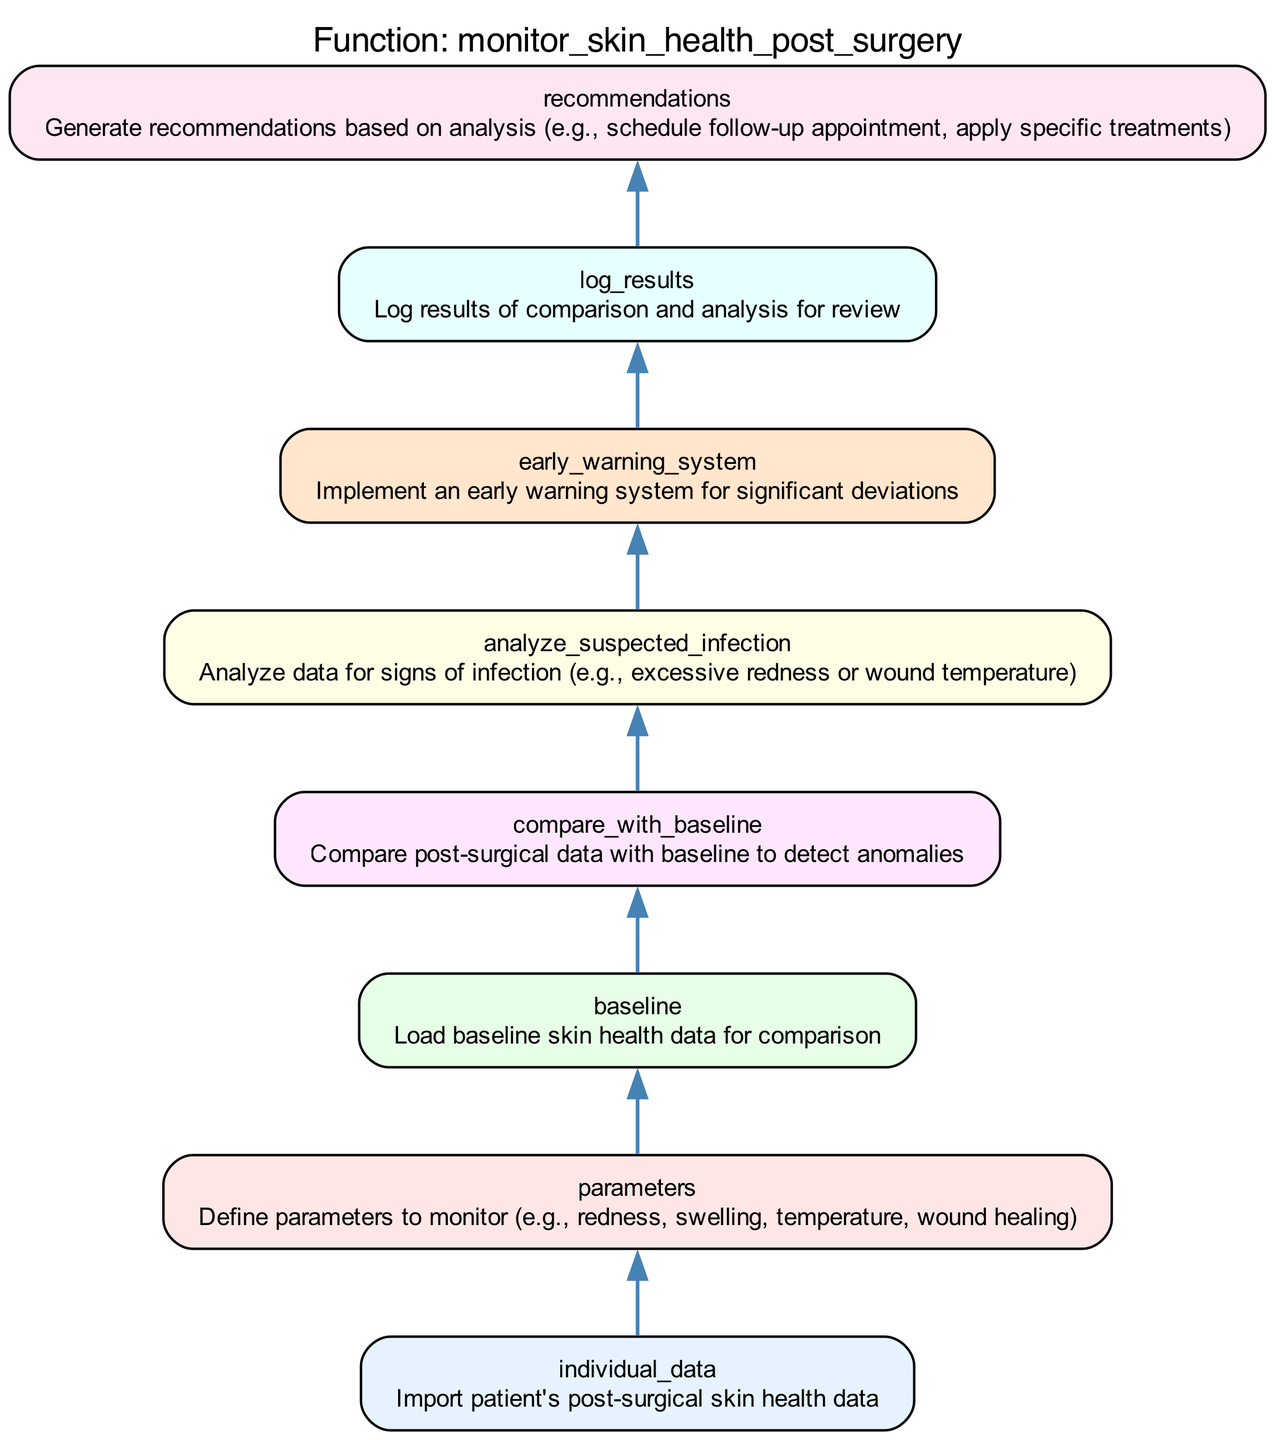What is the first step in the function? The first step, labeled "individual_data", indicates that the function starts by importing the patient's post-surgical skin health data, which is the initial action taken before any processing.
Answer: Import patient's post-surgical skin health data How many nodes are there in total? By counting all the distinct elements in the flowchart, we find that there are a total of eight nodes representing different stages in the monitoring process.
Answer: Eight What follows the "analyze_suspected_infection"? The "early_warning_system" follows the "analyze_suspected_infection" step in the flowchart, indicating the next action after analyzing for signs of infection.
Answer: Implement an early warning system for significant deviations What is the purpose of the "log_results"? The "log_results" step serves to record the outcomes of the analysis and comparison processes, ensuring that results are documented for future reference or review.
Answer: Log results of comparison and analysis for review Which step is responsible for generating recommendations? The final step in the process, "recommendations", is responsible for creating suggestions based on the earlier analysis, indicating possible actions to take after monitoring is complete.
Answer: Generate recommendations based on analysis 